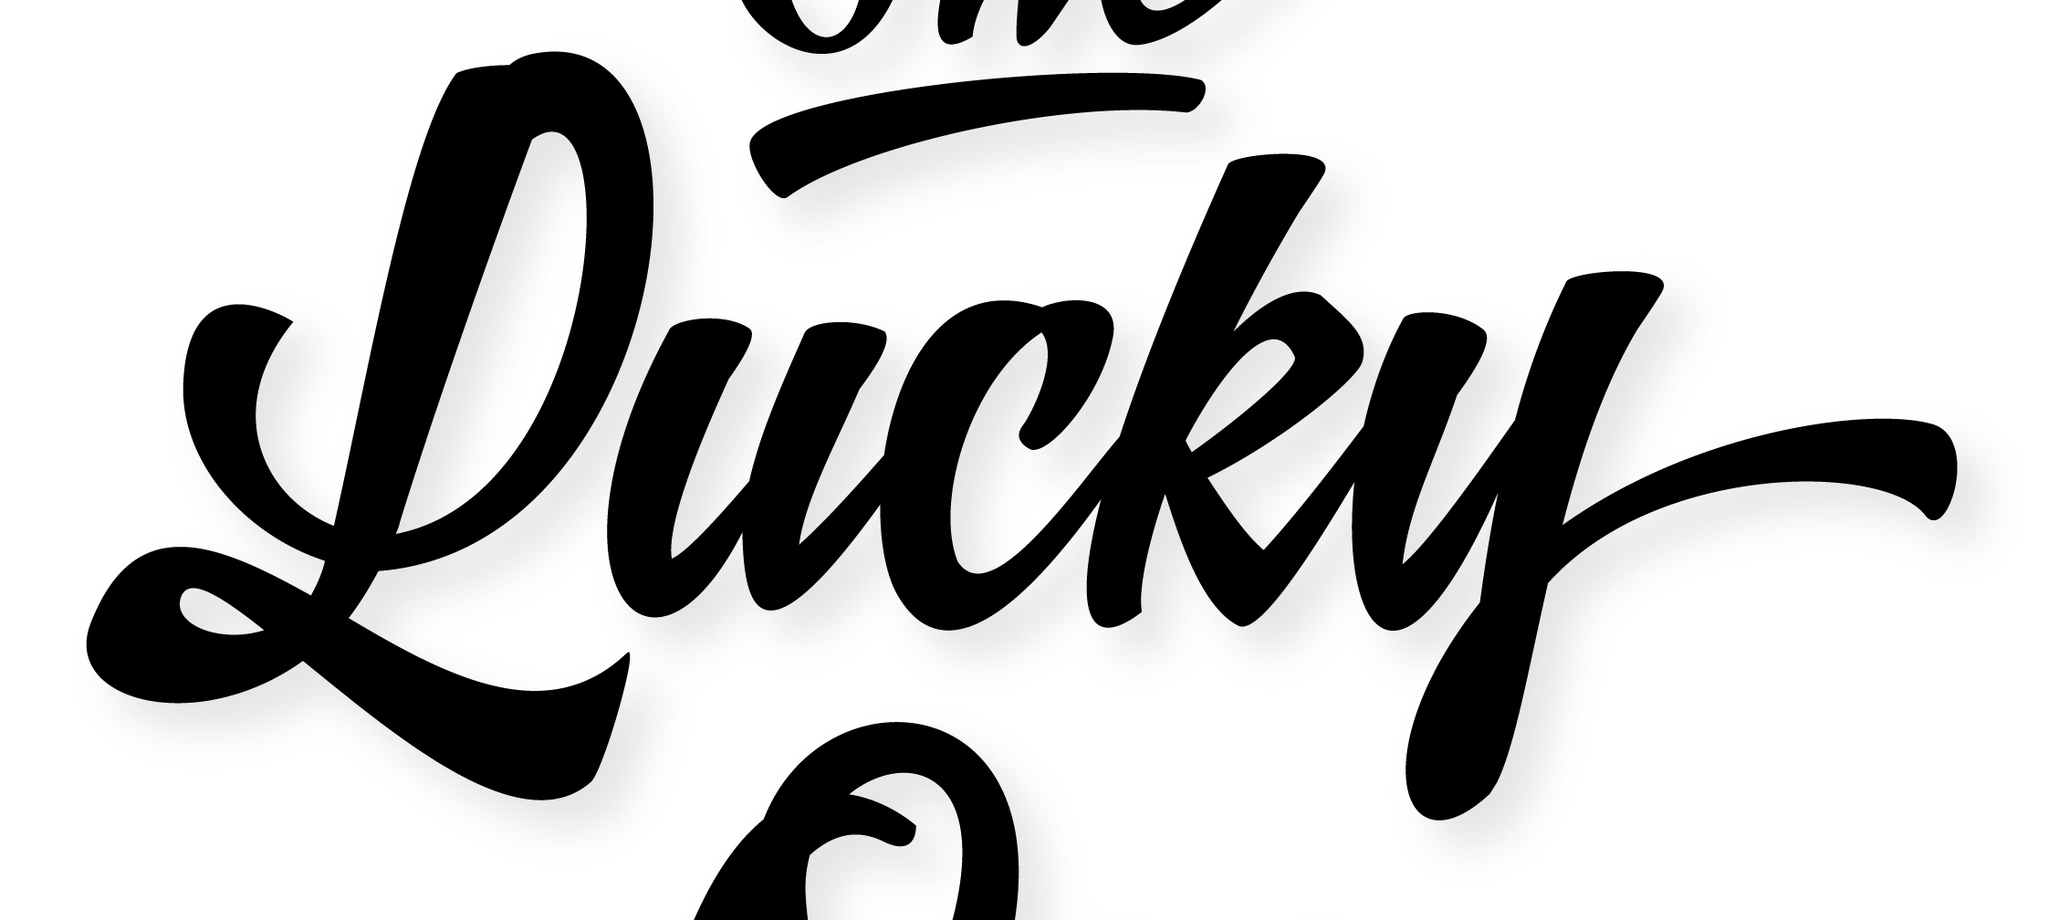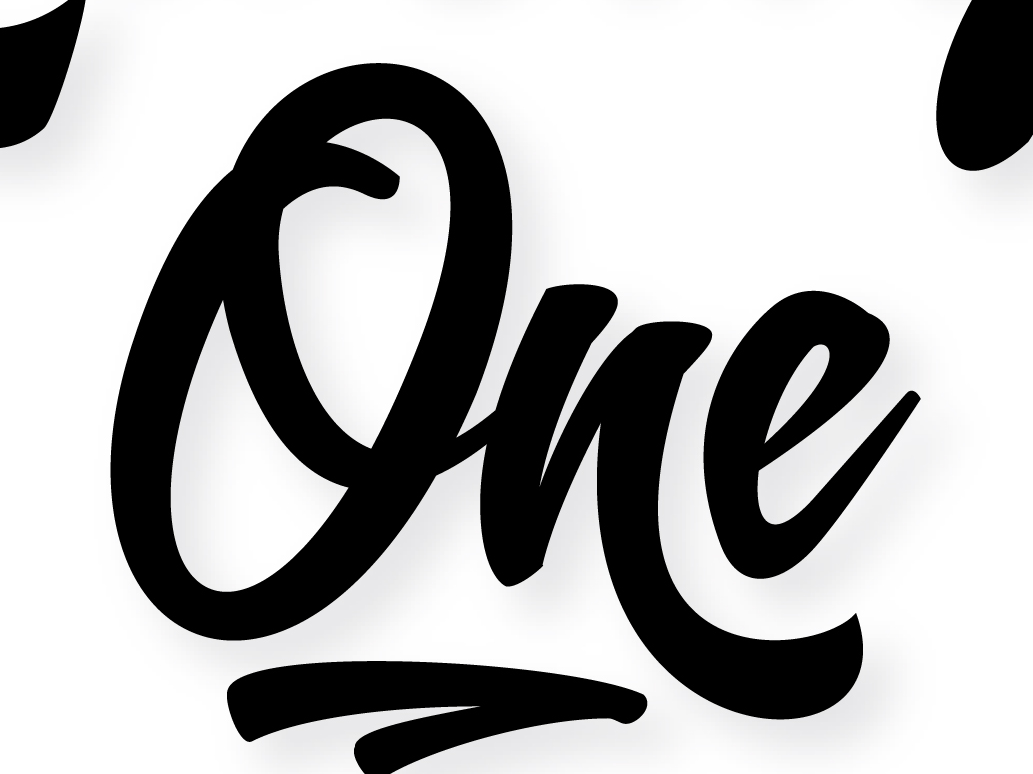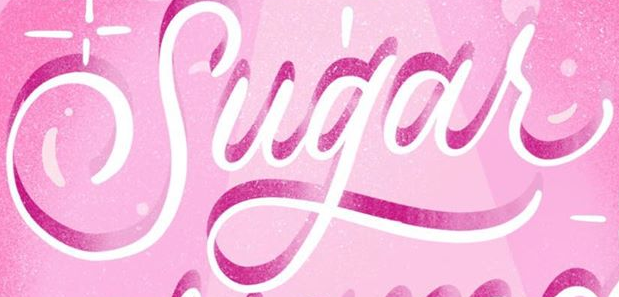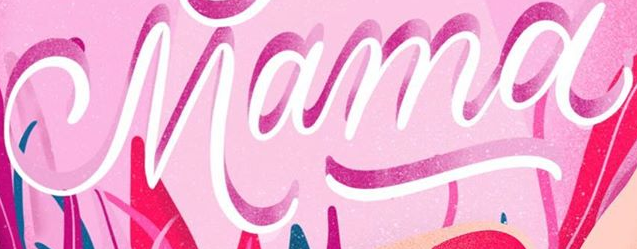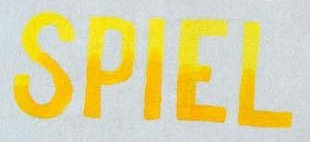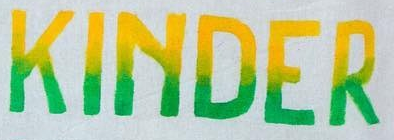What text is displayed in these images sequentially, separated by a semicolon? Lucky; One; Sugar; Mama; SPIEL; KINDER 